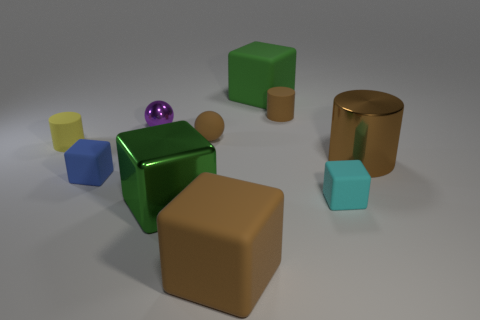Subtract all big brown cylinders. How many cylinders are left? 2 Subtract 3 blocks. How many blocks are left? 2 Subtract all brown cylinders. How many brown spheres are left? 1 Subtract all cyan matte blocks. Subtract all large green rubber cubes. How many objects are left? 8 Add 2 brown spheres. How many brown spheres are left? 3 Add 6 tiny matte balls. How many tiny matte balls exist? 7 Subtract all blue cubes. How many cubes are left? 4 Subtract 0 gray spheres. How many objects are left? 10 Subtract all cylinders. How many objects are left? 7 Subtract all red cubes. Subtract all gray cylinders. How many cubes are left? 5 